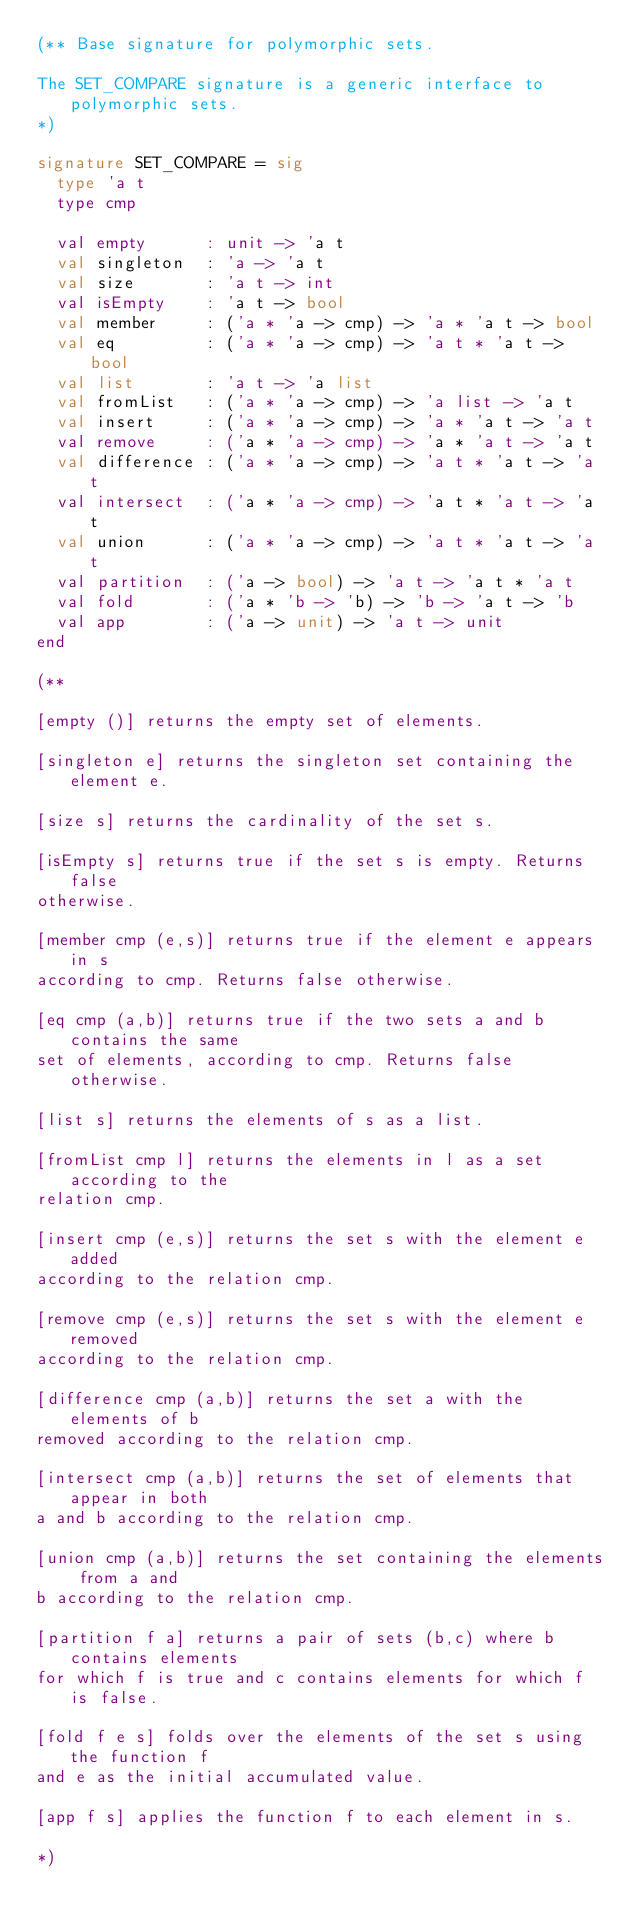<code> <loc_0><loc_0><loc_500><loc_500><_SML_>(** Base signature for polymorphic sets.

The SET_COMPARE signature is a generic interface to polymorphic sets.
*)

signature SET_COMPARE = sig
  type 'a t
  type cmp

  val empty      : unit -> 'a t
  val singleton  : 'a -> 'a t
  val size       : 'a t -> int
  val isEmpty    : 'a t -> bool
  val member     : ('a * 'a -> cmp) -> 'a * 'a t -> bool
  val eq         : ('a * 'a -> cmp) -> 'a t * 'a t -> bool
  val list       : 'a t -> 'a list
  val fromList   : ('a * 'a -> cmp) -> 'a list -> 'a t
  val insert     : ('a * 'a -> cmp) -> 'a * 'a t -> 'a t
  val remove     : ('a * 'a -> cmp) -> 'a * 'a t -> 'a t
  val difference : ('a * 'a -> cmp) -> 'a t * 'a t -> 'a t
  val intersect  : ('a * 'a -> cmp) -> 'a t * 'a t -> 'a t
  val union      : ('a * 'a -> cmp) -> 'a t * 'a t -> 'a t
  val partition  : ('a -> bool) -> 'a t -> 'a t * 'a t
  val fold       : ('a * 'b -> 'b) -> 'b -> 'a t -> 'b
  val app        : ('a -> unit) -> 'a t -> unit
end

(**

[empty ()] returns the empty set of elements.

[singleton e] returns the singleton set containing the element e.

[size s] returns the cardinality of the set s.

[isEmpty s] returns true if the set s is empty. Returns false
otherwise.

[member cmp (e,s)] returns true if the element e appears in s
according to cmp. Returns false otherwise.

[eq cmp (a,b)] returns true if the two sets a and b contains the same
set of elements, according to cmp. Returns false otherwise.

[list s] returns the elements of s as a list.

[fromList cmp l] returns the elements in l as a set according to the
relation cmp.

[insert cmp (e,s)] returns the set s with the element e added
according to the relation cmp.

[remove cmp (e,s)] returns the set s with the element e removed
according to the relation cmp.

[difference cmp (a,b)] returns the set a with the elements of b
removed according to the relation cmp.

[intersect cmp (a,b)] returns the set of elements that appear in both
a and b according to the relation cmp.

[union cmp (a,b)] returns the set containing the elements from a and
b according to the relation cmp.

[partition f a] returns a pair of sets (b,c) where b contains elements
for which f is true and c contains elements for which f is false.

[fold f e s] folds over the elements of the set s using the function f
and e as the initial accumulated value.

[app f s] applies the function f to each element in s.

*)
</code> 